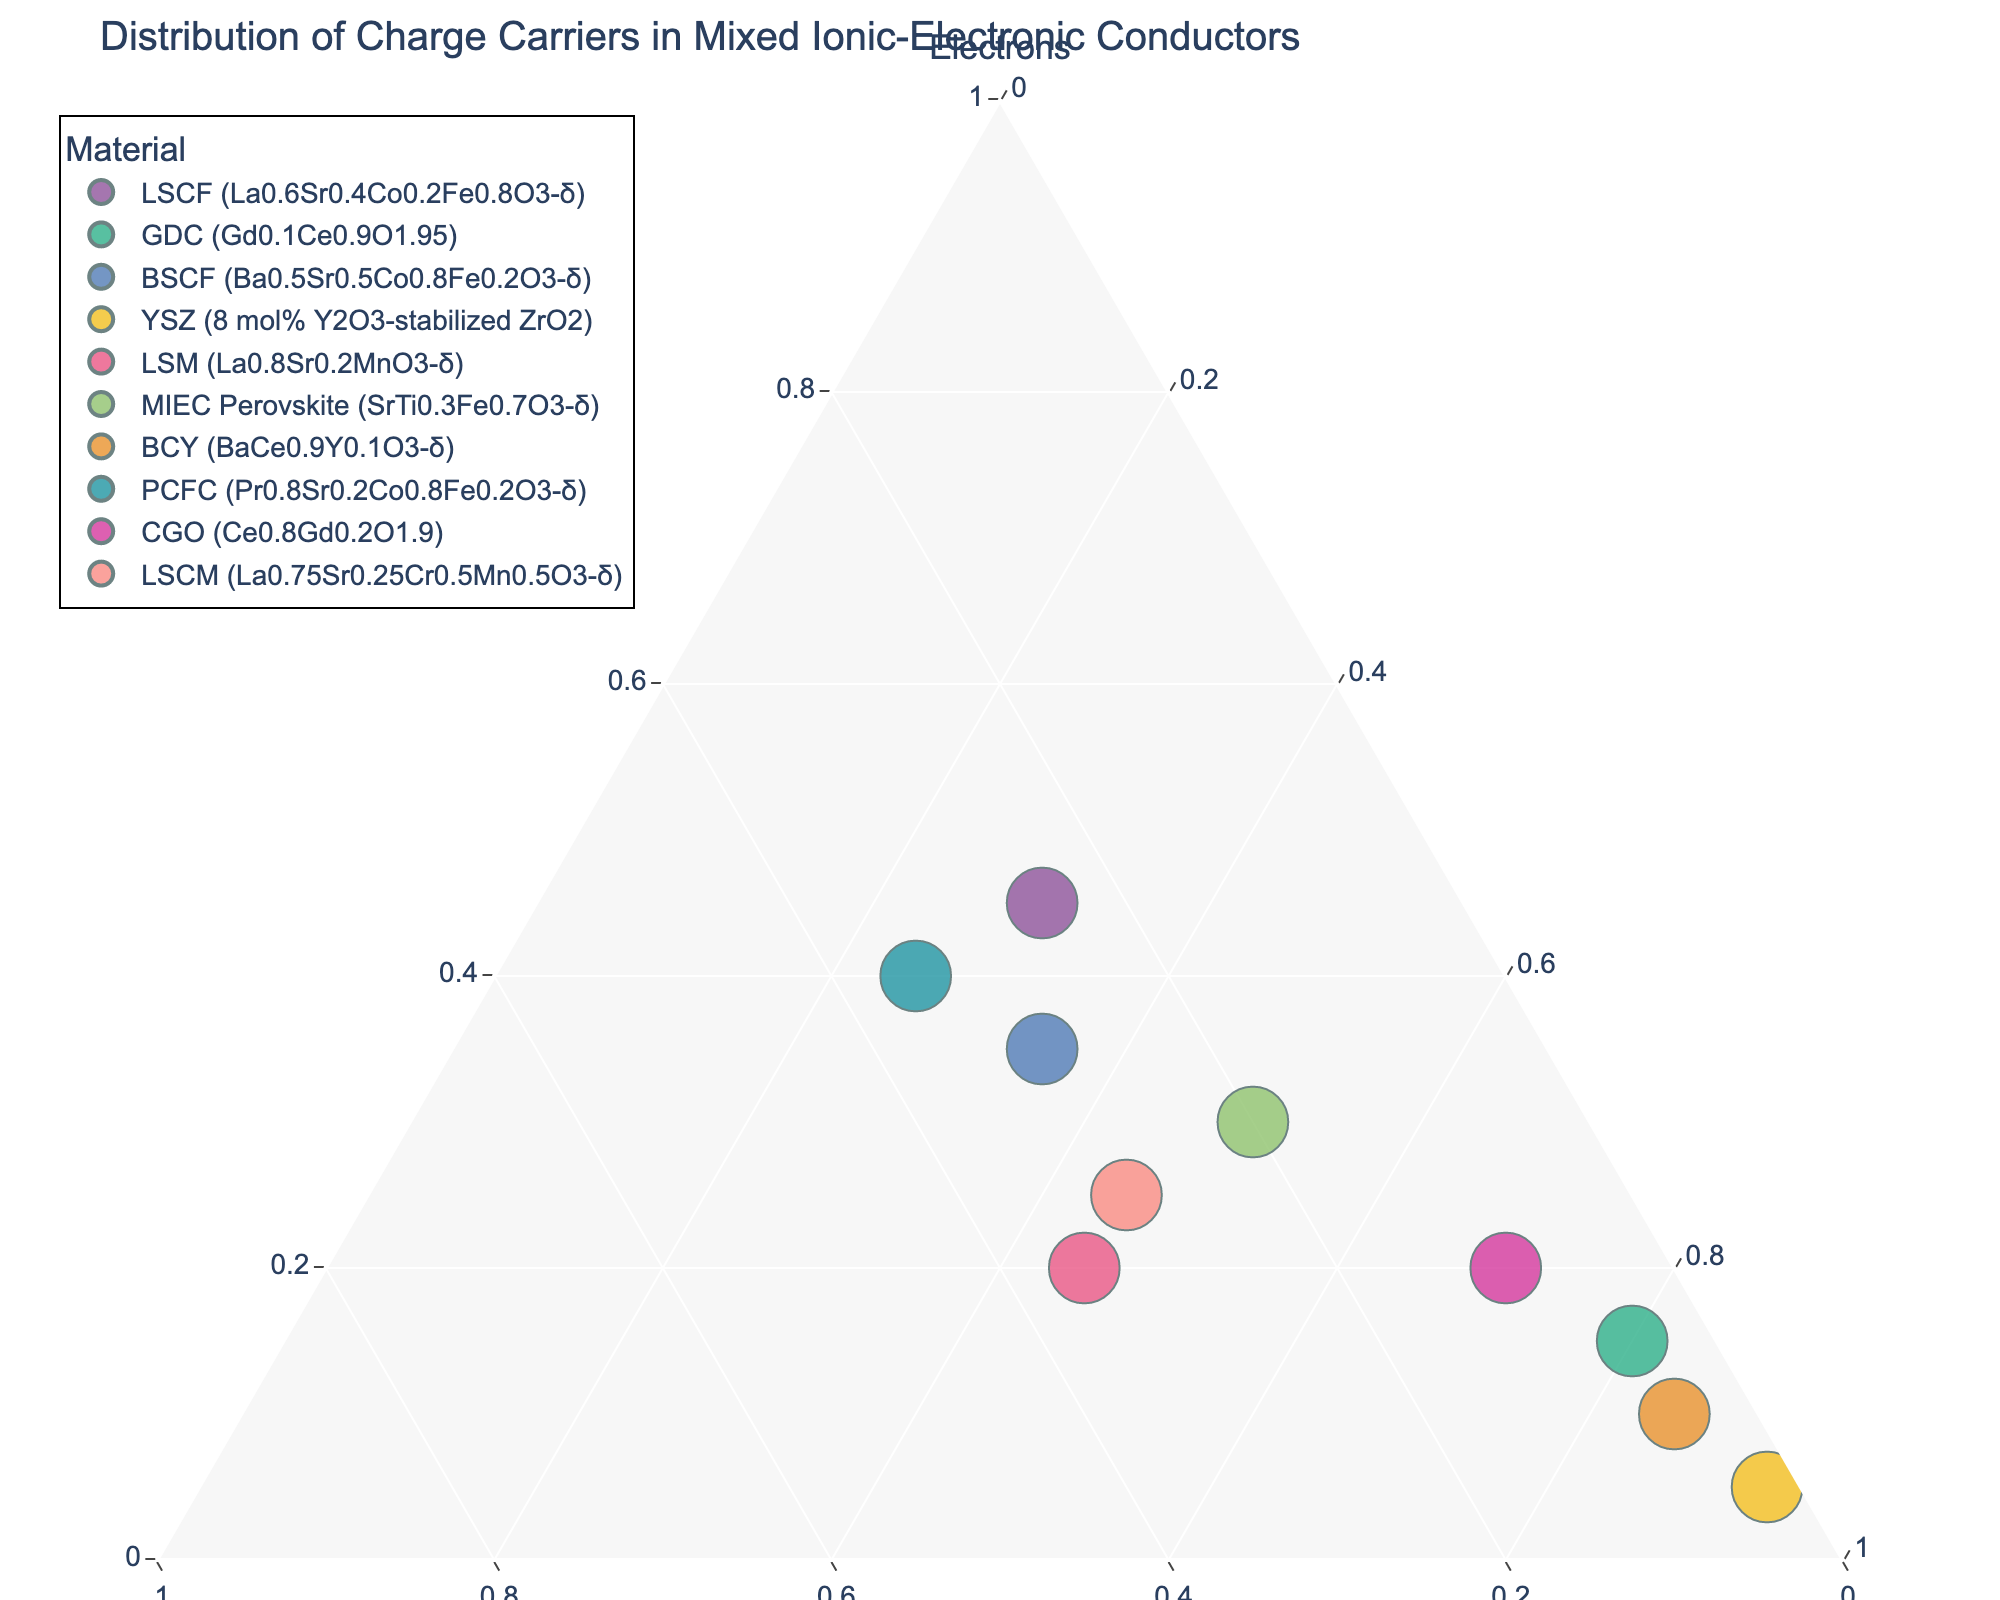what is the title of the plot? The title of the plot is located at the top and it provides a brief idea about the content and purpose of the plot. By reading the top of the figure, we can find that it is "Distribution of Charge Carriers in Mixed Ionic-Electronic Conductors".
Answer: Distribution of Charge Carriers in Mixed Ionic-Electronic Conductors Which material has the highest proportion of ions? To identify the material with the highest proportion of ions, observe the position closest to the "Ions" axis. The material substantially nearest to the "Ions" corner is YSZ (8 mol% Y2O3-stabilized ZrO2).
Answer: YSZ (8 mol% Y2O3-stabilized ZrO2) How many data points are displayed? Count the individual markers present in the plot. Since each material has a unique marker, the total number of data points equals the number of distinct markers. By counting, you observe 10 markers.
Answer: 10 Which two materials have the closest proportion of holes? Compare the position of each material along the "Holes" axis. LSM (La0.8Sr0.2MnO3-δ) and PCFC (Pr0.8Sr0.2Co0.8Fe0.2O3-δ) are the closest to each other, considering their horizontal alignment and proximity to the "Holes" axis.
Answer: LSM and PCFC What is the combined proportion of electrons and ions for LSCF (La0.6Sr0.4Co0.2Fe0.8O3-δ)? To calculate the combined proportion, sum the proportions of electrons and ions for LSCF. From the plot, LSCF has 0.45 electrons and 0.30 ions. Adding these together gives: 0.45+0.30=0.75.
Answer: 0.75 Which material has the most balanced distribution of charge carriers? A balanced distribution implies more equal proportions of electrons, holes, and ions. Observe which marker is closest to the geometric center of the ternary plot. BSCF (Ba0.5Sr0.5Co0.8Fe0.2O3-δ) appears closest to the center, indicating a more balanced charge carrier distribution.
Answer: BSCF How does the proportion of electrons in CGO (Ce0.8Gd0.2O1.9) compare to that in BCY (BaCe0.9Y0.1O3-δ)? Compare their positions along the "Electrons" axis. CGO is situated higher on the "Electrons" axis than BCY, which indicates that CGO has a higher proportion of electrons than BCY.
Answer: CGO has a higher proportion of electrons Which materials are predominantly ionic conductors? Identify the materials positioned closest to the "Ions" vertex, meaning they have a greater proportion of ions relative to electrons and holes. The materials YSZ and BCY are noticeably near the "Ions" vertex, indicating high ionic conduction.
Answer: YSZ and BCY What is the combined proportion of electrons and holes for LSCM (La0.75Sr0.25Cr0.5Mn0.5O3-δ)? Sum the proportions of electrons and holes for LSCM. From the plot, LSCM shows 0.25 electrons and 0.30 holes. Adding these two proportions together provides: 0.25+0.30=0.55.
Answer: 0.55 What can be inferred about the proportion of electrons and holes in PCFC (Pr0.8Sr0.2Co0.8Fe0.2O3-δ)? Since PCFC is positioned relatively equidistant from both the "Electrons" and "Holes" vertices, it suggests a roughly equal proportion of electrons and holes.
Answer: Roughly equal proportion of electrons and holes 